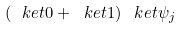<formula> <loc_0><loc_0><loc_500><loc_500>\left ( \ k e t { 0 } + \ k e t { 1 } \right ) \ k e t { \psi _ { j } }</formula> 